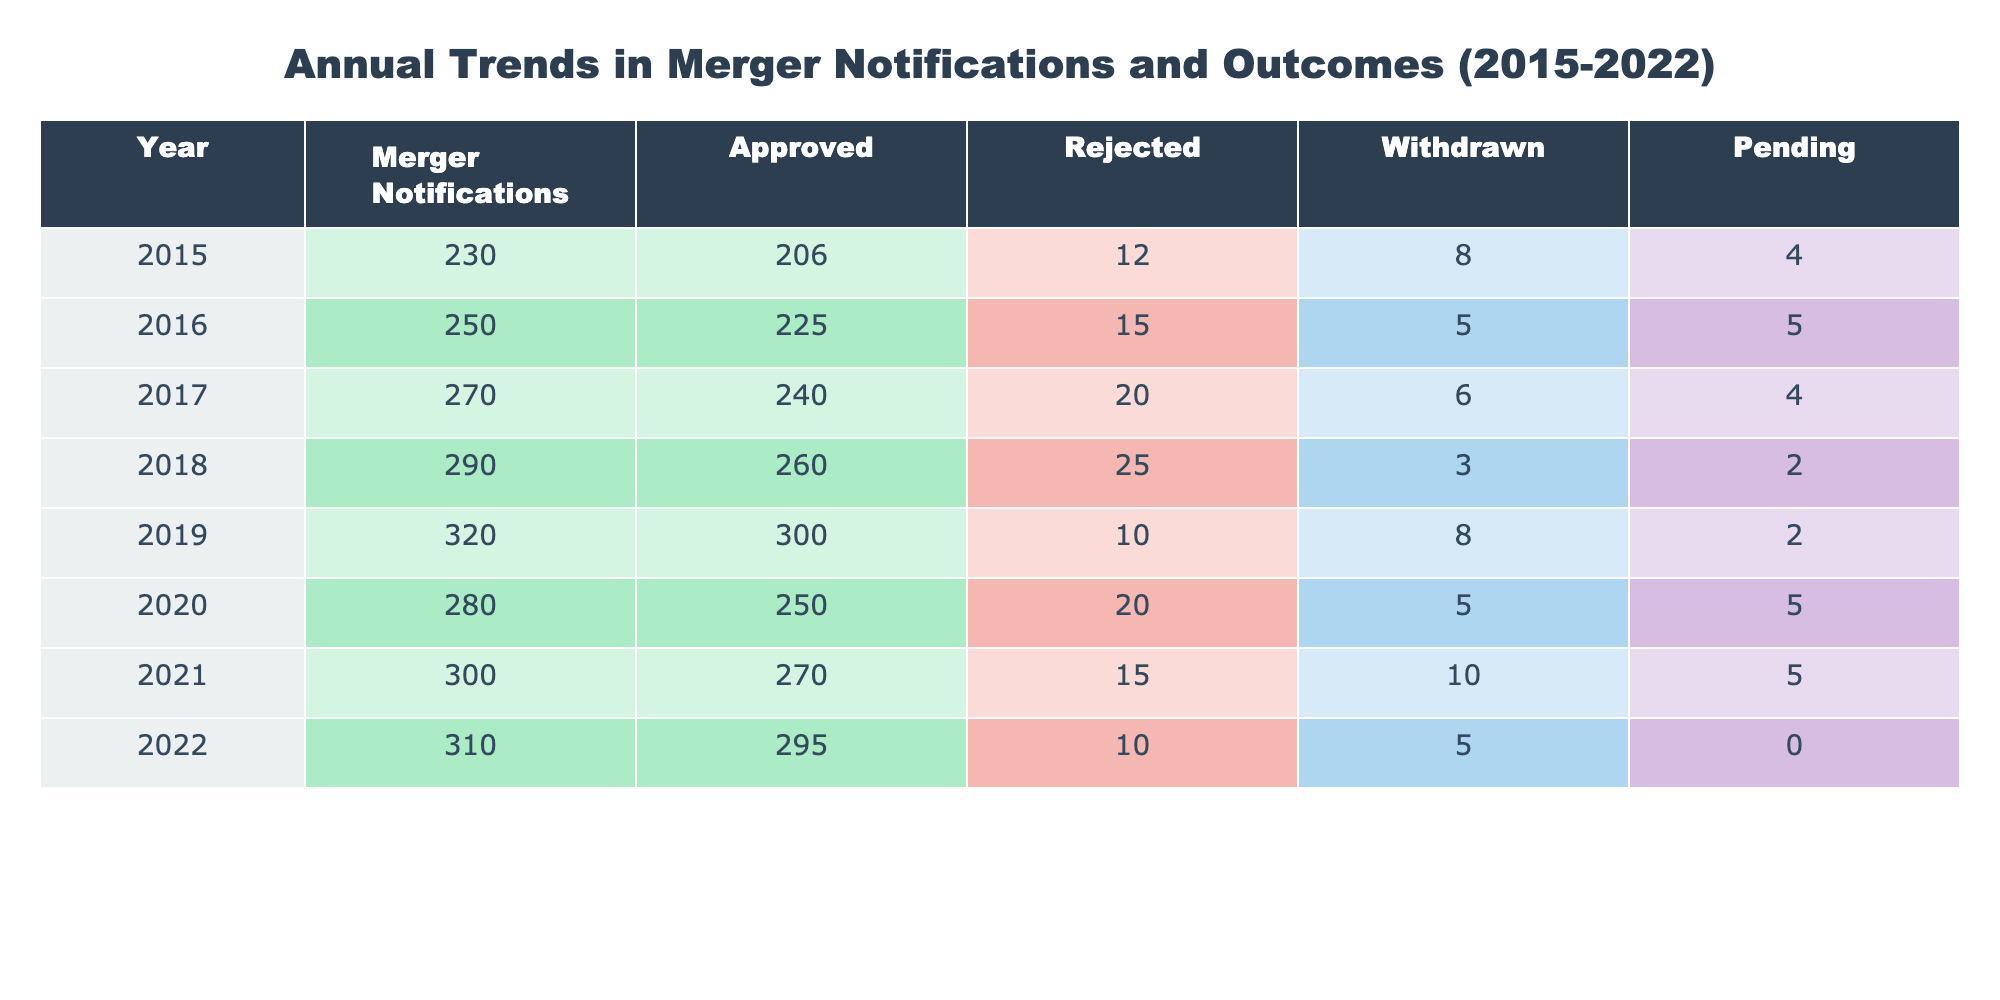What was the total number of merger notifications in 2019? In 2019, the table shows that there were 320 merger notifications. This is directly retrievable from the corresponding row.
Answer: 320 What was the percentage of approved mergers in 2020? To find the percentage of approved mergers in 2020, take the number of approved (250) and divide it by the total notifications (280), then multiply by 100: (250/280) * 100 = 89.29%.
Answer: 89.29% Were there more approved mergers than withdrawn mergers in 2016? In 2016, there were 225 approved mergers and 5 withdrawn mergers. Since 225 is greater than 5, the answer is yes.
Answer: Yes What year had the highest number of rejections, and how many were there? By inspecting the table, 2018 shows the highest number of rejections at 25. This is the maximum value found across all years in the 'Rejected' column.
Answer: 2018, 25 What is the average number of pending merger notifications from 2015 to 2022? To calculate the average of pending notifications, sum the pending numbers: (4 + 5 + 4 + 2 + 2 + 5 + 5 + 0) = 27. There are 8 years total, so the average is 27/8 = 3.375.
Answer: 3.375 In which year did the number of merger notifications decrease compared to the previous year? By comparing the total notifications from year to year, it can be seen that there was a decrease in 2020, where notifications dropped from 320 in 2019 to 280. Therefore, the year is 2020.
Answer: 2020 How many more mergers were approved in 2022 than in 2015? In 2022, there were 295 approved mergers and in 2015 there were 206. The difference is 295 - 206 = 89.
Answer: 89 Was the number of total merger notifications in 2021 greater than the combined total of rejected and withdrawn notifications in that year? In 2021, the total notifications were 300, and the sum of rejected (15) and withdrawn (10) notifications was 25. Since 300 is greater than 25, the answer is yes.
Answer: Yes 